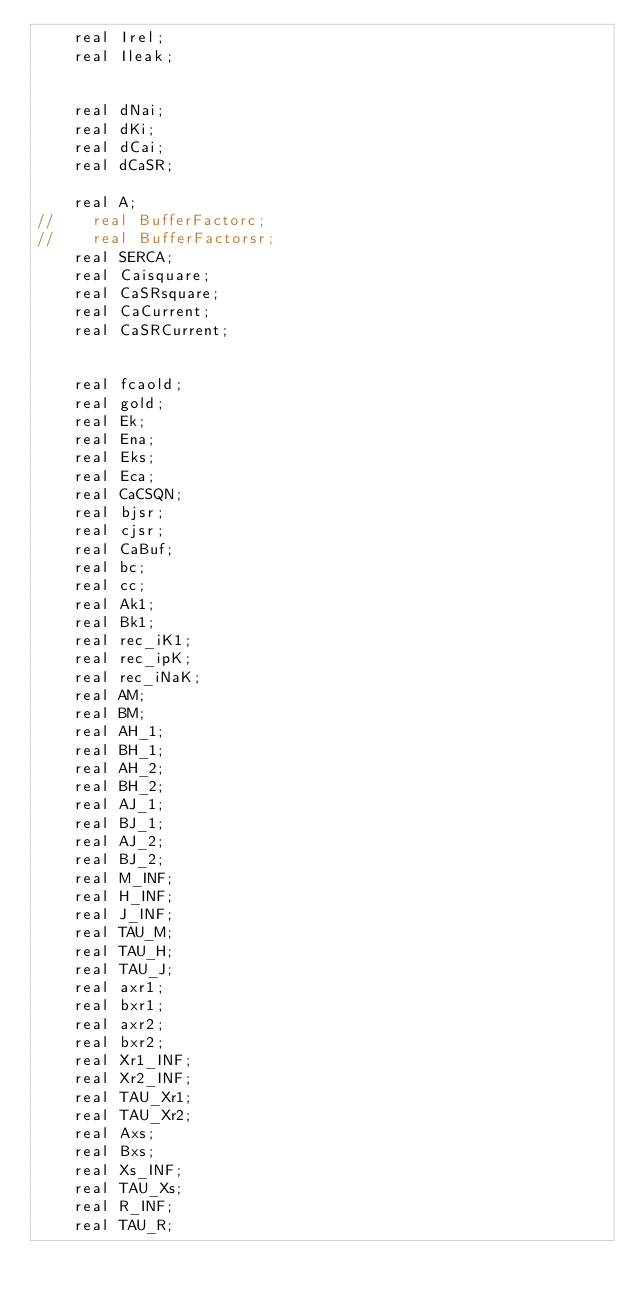Convert code to text. <code><loc_0><loc_0><loc_500><loc_500><_Cuda_>    real Irel;
    real Ileak;


    real dNai;
    real dKi;
    real dCai;
    real dCaSR;

    real A;
//    real BufferFactorc;
//    real BufferFactorsr;
    real SERCA;
    real Caisquare;
    real CaSRsquare;
    real CaCurrent;
    real CaSRCurrent;


    real fcaold;
    real gold;
    real Ek;
    real Ena;
    real Eks;
    real Eca;
    real CaCSQN;
    real bjsr;
    real cjsr;
    real CaBuf;
    real bc;
    real cc;
    real Ak1;
    real Bk1;
    real rec_iK1;
    real rec_ipK;
    real rec_iNaK;
    real AM;
    real BM;
    real AH_1;
    real BH_1;
    real AH_2;
    real BH_2;
    real AJ_1;
    real BJ_1;
    real AJ_2;
    real BJ_2;
    real M_INF;
    real H_INF;
    real J_INF;
    real TAU_M;
    real TAU_H;
    real TAU_J;
    real axr1;
    real bxr1;
    real axr2;
    real bxr2;
    real Xr1_INF;
    real Xr2_INF;
    real TAU_Xr1;
    real TAU_Xr2;
    real Axs;
    real Bxs;
    real Xs_INF;
    real TAU_Xs;
    real R_INF;
    real TAU_R;</code> 